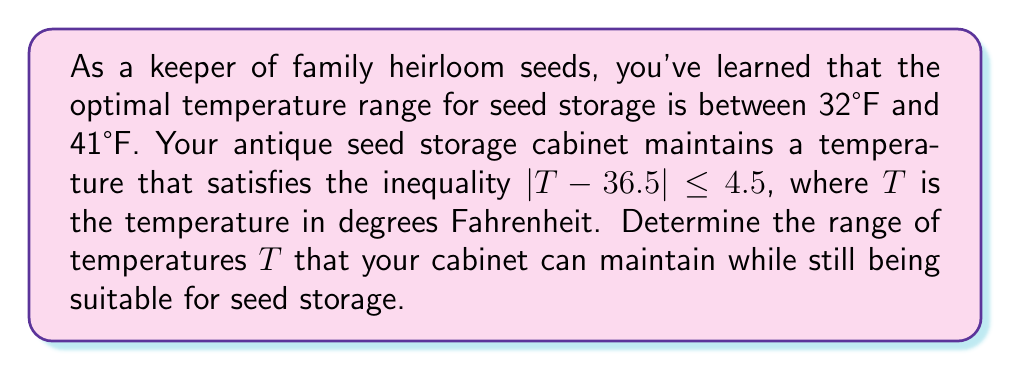Could you help me with this problem? 1) The inequality $|T - 36.5| \leq 4.5$ represents the temperature range of the cabinet.

2) To solve this, we need to consider two cases:
   Case 1: $T - 36.5 \leq 4.5$
   Case 2: $-(T - 36.5) \leq 4.5$

3) For Case 1:
   $T - 36.5 \leq 4.5$
   $T \leq 41$

4) For Case 2:
   $-(T - 36.5) \leq 4.5$
   $-T + 36.5 \leq 4.5$
   $-T \leq -32$
   $T \geq 32$

5) Combining the results from both cases:
   $32 \leq T \leq 41$

6) The optimal temperature range for seed storage is 32°F to 41°F.

7) The cabinet's temperature range (32°F to 41°F) exactly matches the optimal range for seed storage.

Therefore, the cabinet can maintain temperatures between 32°F and 41°F, which is suitable for storing heirloom seeds.
Answer: $[32, 41]$ in °F 